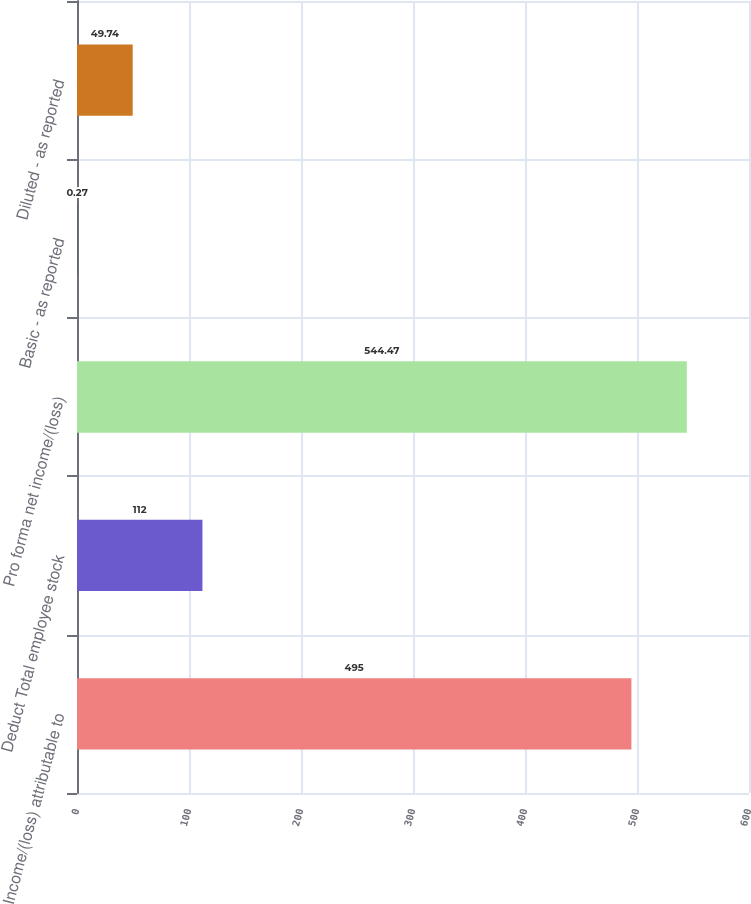Convert chart to OTSL. <chart><loc_0><loc_0><loc_500><loc_500><bar_chart><fcel>Income/(loss) attributable to<fcel>Deduct Total employee stock<fcel>Pro forma net income/(loss)<fcel>Basic - as reported<fcel>Diluted - as reported<nl><fcel>495<fcel>112<fcel>544.47<fcel>0.27<fcel>49.74<nl></chart> 